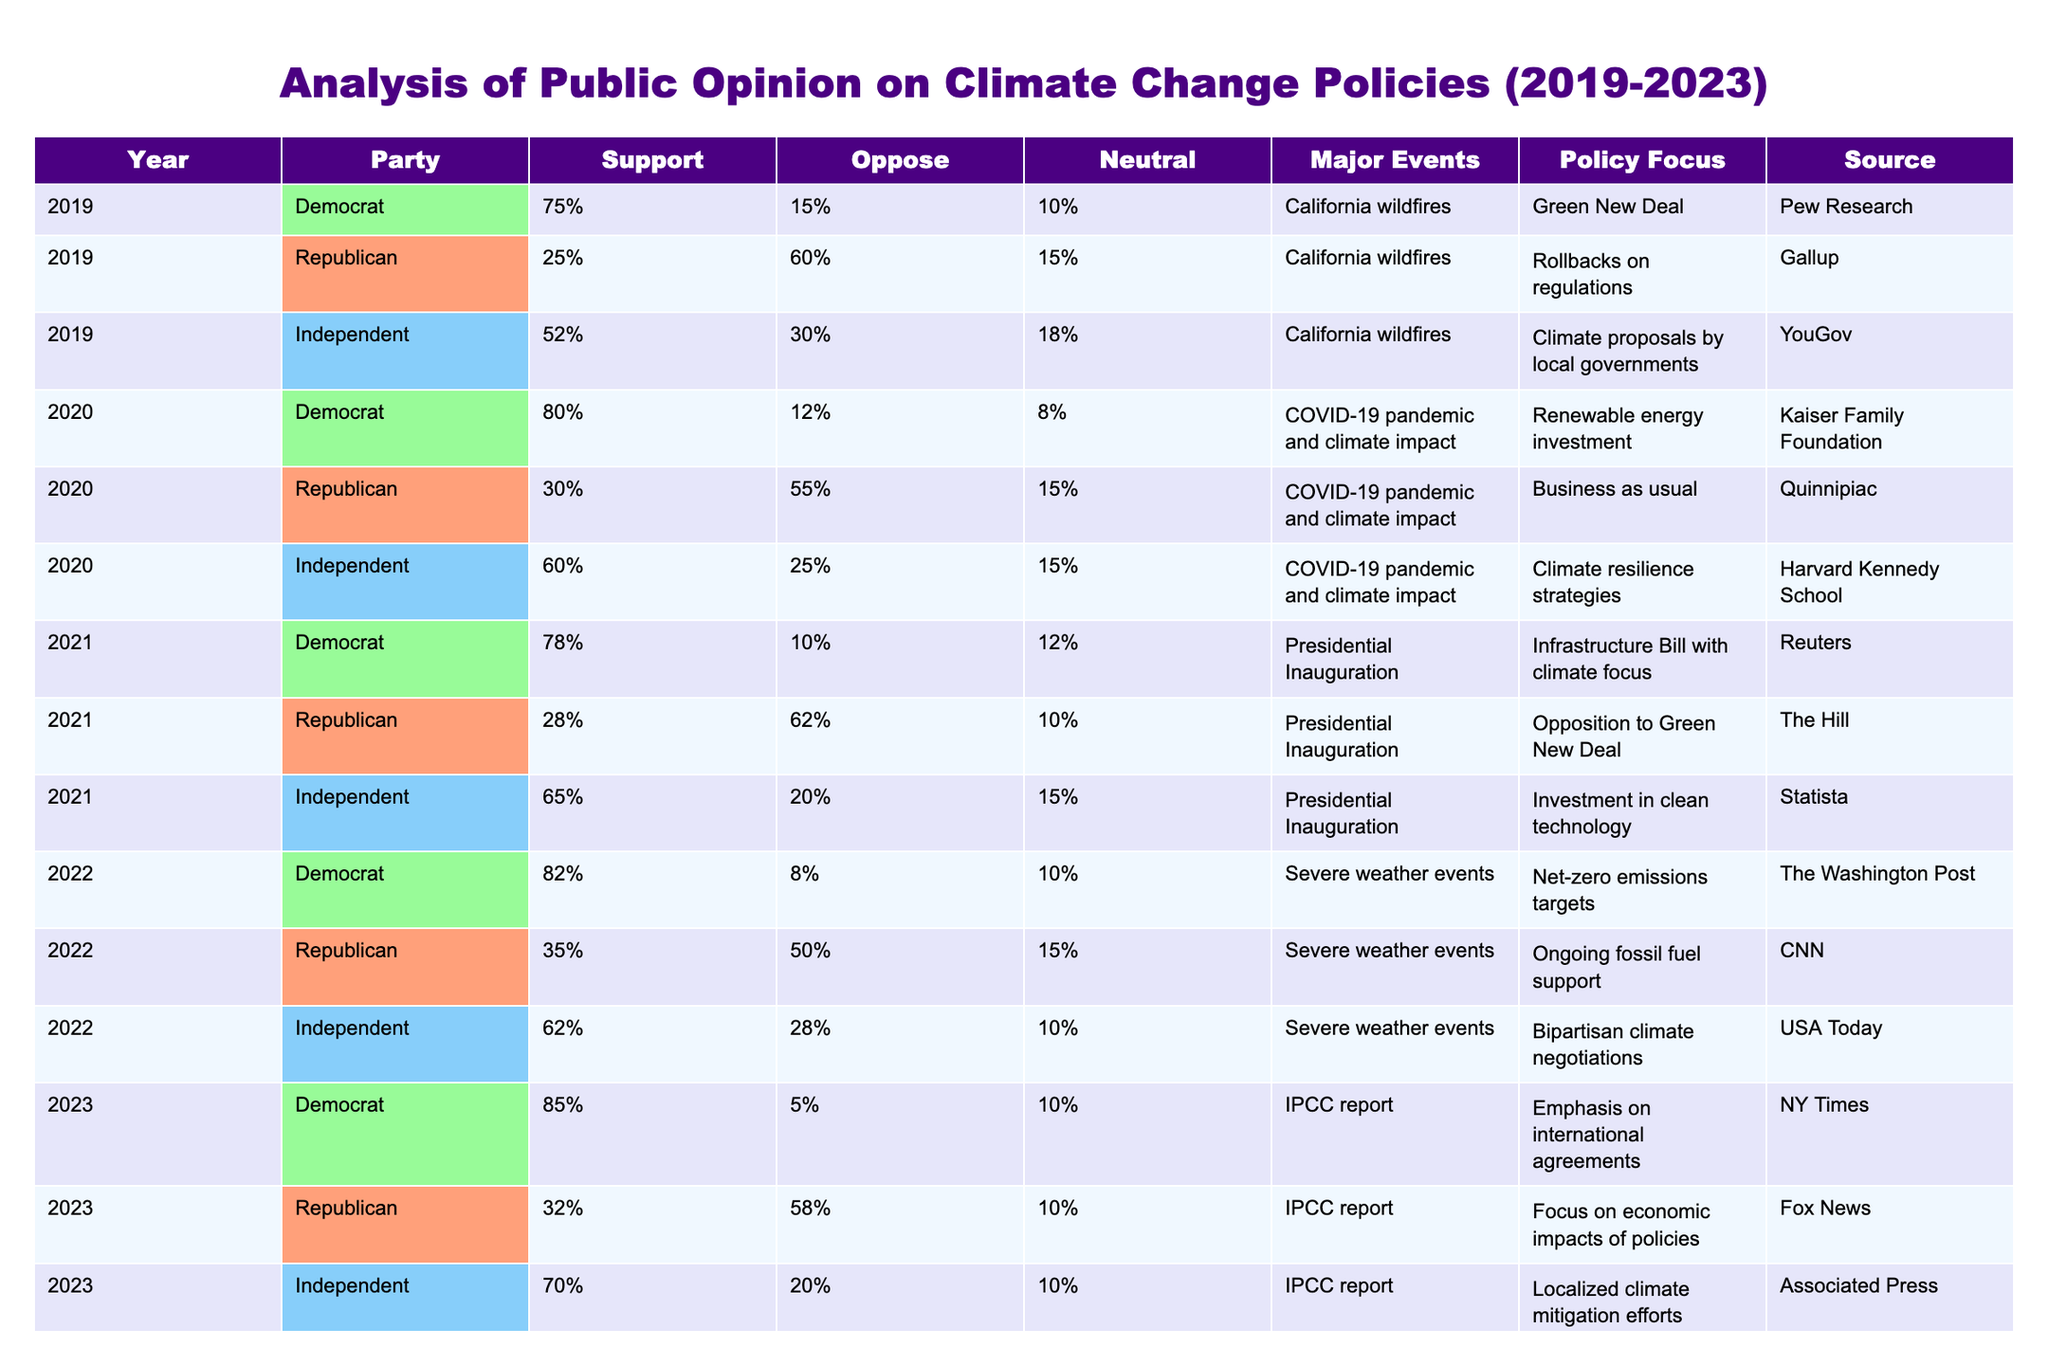What percentage of Democrats supported climate change policies in 2022? In 2022, the table shows that 82% of Democrats supported climate change policies.
Answer: 82% What was the opposition percentage for Republicans in 2020? According to the table, Republicans opposed climate change policies at a rate of 55% in 2020.
Answer: 55% What are the major events listed for the year 2021? The table indicates that the major event in 2021 was the Presidential Inauguration.
Answer: Presidential Inauguration Calculate the average support for Independent voters from 2019 to 2023. The support percentages for Independent voters over the years are 52%, 60%, 65%, 62%, and 70%. The sum of these values is 52 + 60 + 65 + 62 + 70 = 309. Dividing by the number of years (5), we get 309 / 5 = 61.8, which can be rounded to 62%.
Answer: 62% True or False: Support for climate change policies among Democrats increased from 2019 to 2023. By comparing the percentages from the table, Democrats showed support of 75% in 2019 and 85% in 2023, indicating an increase. Therefore, this statement is true.
Answer: True Which party had the highest support for climate change policies in 2023? The table shows that in 2023, Democrats had the highest support with 85%, compared to 32% for Republicans and 70% for Independents.
Answer: Democrats What is the difference in opposition percentages between Republicans in 2023 and Independents in 2022? From the table, Republicans opposed climate change policies at 58% in 2023, while Independents opposed at 28% in 2022. The difference is 58% - 28% = 30%.
Answer: 30% What was the policy focus for Independent voters in 2020? The table states that the policy focus for Independent voters in 2020 was on climate resilience strategies.
Answer: Climate resilience strategies Identify which source reported the support for Democrats in 2021. The table indicates that the source for the support of Democrats in 2021 was Reuters.
Answer: Reuters How did the support for climate change policies among Republicans change from 2019 to 2022? In 2019, Republicans had a support level of 25%, which increased to 35% in 2022. This shows an increase of 10 percentage points over these years.
Answer: Increased by 10 percentage points 